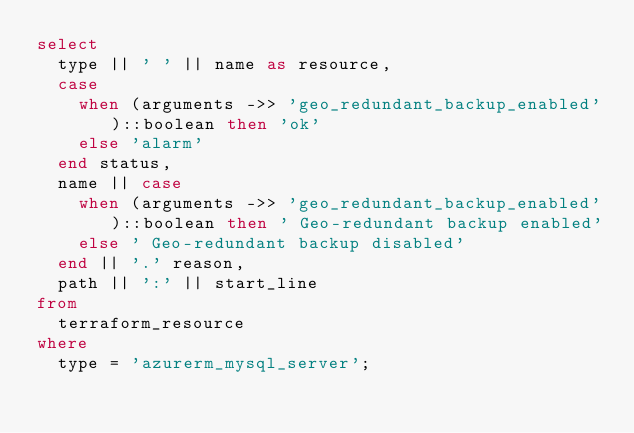Convert code to text. <code><loc_0><loc_0><loc_500><loc_500><_SQL_>select
  type || ' ' || name as resource,
  case
    when (arguments ->> 'geo_redundant_backup_enabled')::boolean then 'ok'
    else 'alarm'
  end status,
  name || case
    when (arguments ->> 'geo_redundant_backup_enabled')::boolean then ' Geo-redundant backup enabled'
    else ' Geo-redundant backup disabled'
  end || '.' reason,
  path || ':' || start_line
from
  terraform_resource
where
  type = 'azurerm_mysql_server';
</code> 